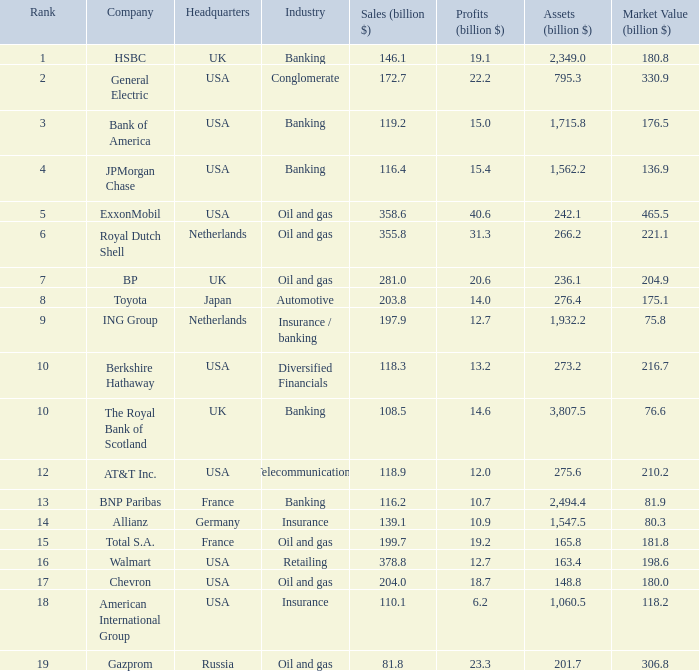What is the top position held by a firm with 1,715.8 billion dollars in assets? 3.0. 